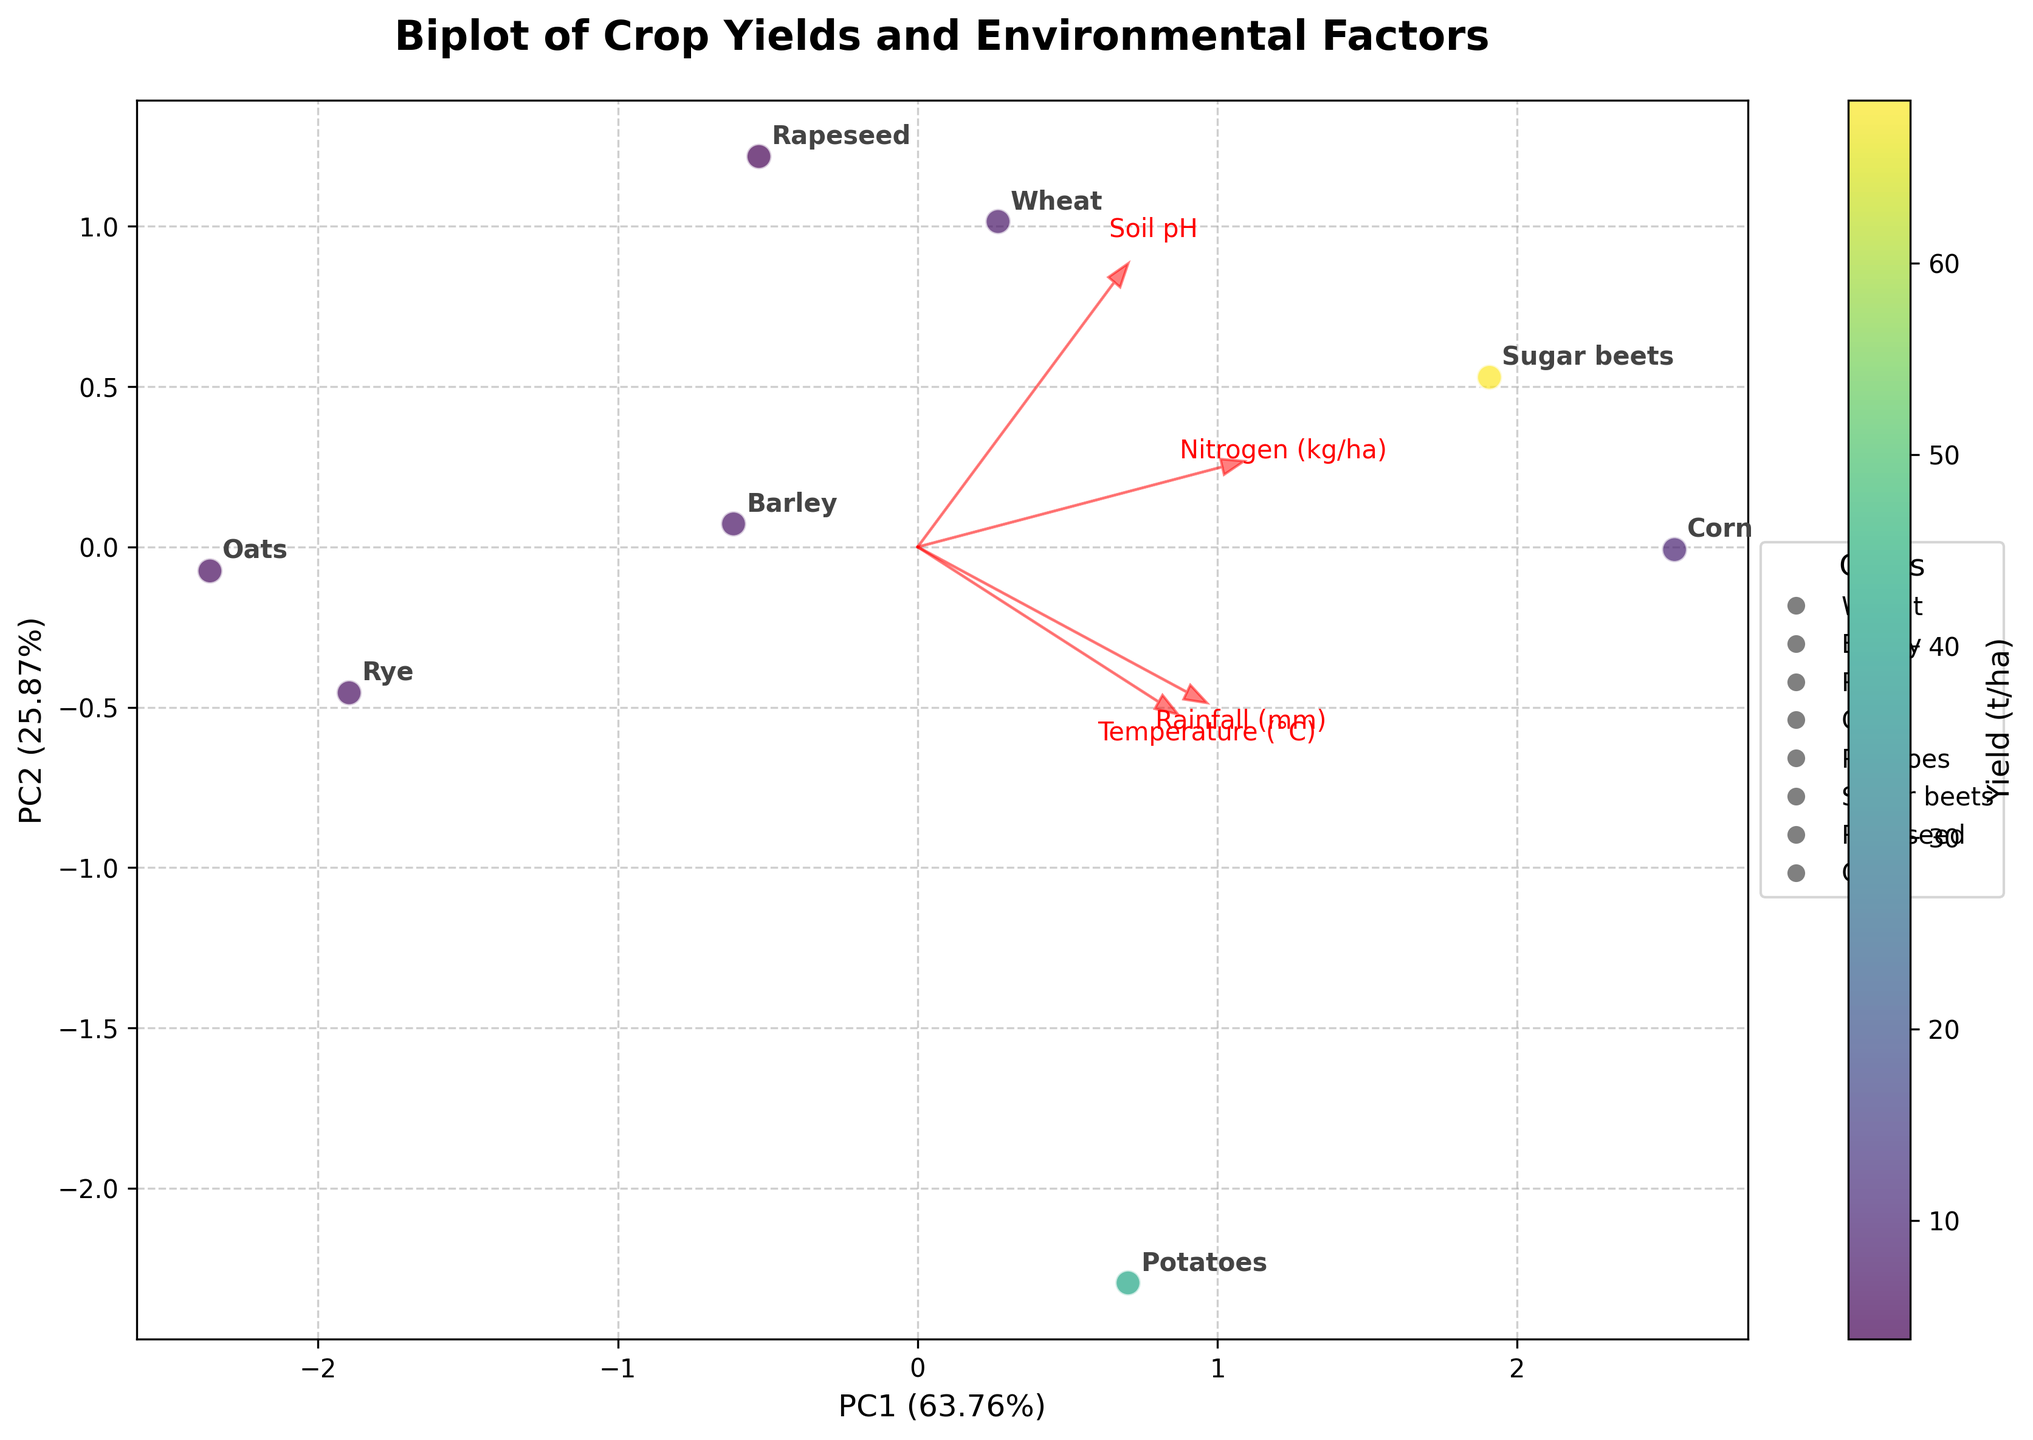What does the title of the biplot say? The title is at the top of the biplot and usually describes what the plot represents.
Answer: Biplot of Crop Yields and Environmental Factors What are the x-axis and y-axis labels of the biplot? The x-axis and y-axis labels are positioned along their respective axes and indicate what the axes represent.
Answer: PC1 and PC2 Which crop has the highest yield, and where is it positioned on the plot? To find the crop with the highest yield, look at the position of the data points on the plot and refer to the color gradient (lighter colors represent higher yields). Identify the crop label that corresponds to the lightest-colored point.
Answer: Sugar beets; positioned towards the lower center-right How many environmental factors are represented by arrows, and what are they? The number of arrows corresponds to the number of environmental factors being analyzed. Each arrow should have a corresponding label. Count the arrows and identify their labels.
Answer: Four; Rainfall, Temperature, Soil pH, Nitrogen Which environmental factor seems to have the strongest influence on PC1? Check the horizontal component of the arrows representing each environmental factor. The arrow with the longest horizontal projection indicates the strongest influence on PC1.
Answer: Nitrogen Which two crops appear closest to each other in the PC space, and what might this imply? Identify the crop labels that are positioned nearest to each other on the plot. This proximity might imply that these crops have similar environmental factor influences and yield characteristics.
Answer: Barley and Rye; similar environmental influences and yields Compare the yields of Wheat and Corn. Which has a higher yield based on their positions on the plot and the color gradient? Locate the positions of Wheat and Corn on the plot using their labels. Compare their colors to see which is lighter, indicating a higher yield.
Answer: Corn has a higher yield than Wheat What's the approximate percentage of variance explained by the first principal component (PC1)? Refer to the x-axis label, which contains the percentage of variance explained by PC1 written in parentheses.
Answer: Approximately 74.6% What might the direction and length of the arrows for Rainfall and Temperature suggest about their relationship? Look at the direction in which the arrows for Rainfall and Temperature point and their lengths. Similar directions and lengths indicate a correlation or relationship between the two factors.
Answer: Both point roughly in the same direction, suggesting they are positively correlated Is there any crop that seems to be positively influenced by high Soil pH based on the arrow direction? Check the direction of the Soil pH arrow and see which crop(s) lie in the same direction.
Answer: Sugar beets lies in the direction of high Soil pH 